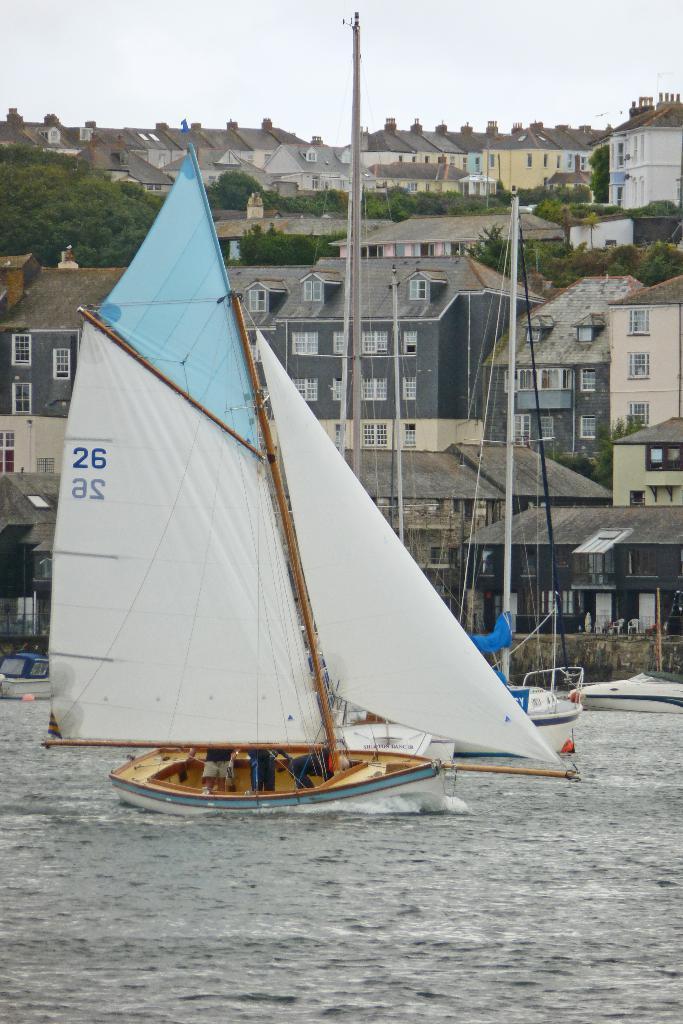Could you give a brief overview of what you see in this image? In this picture we can see there are some people on the boat and the boats are on the water. Behind the boats there are buildings, trees and the sky. 